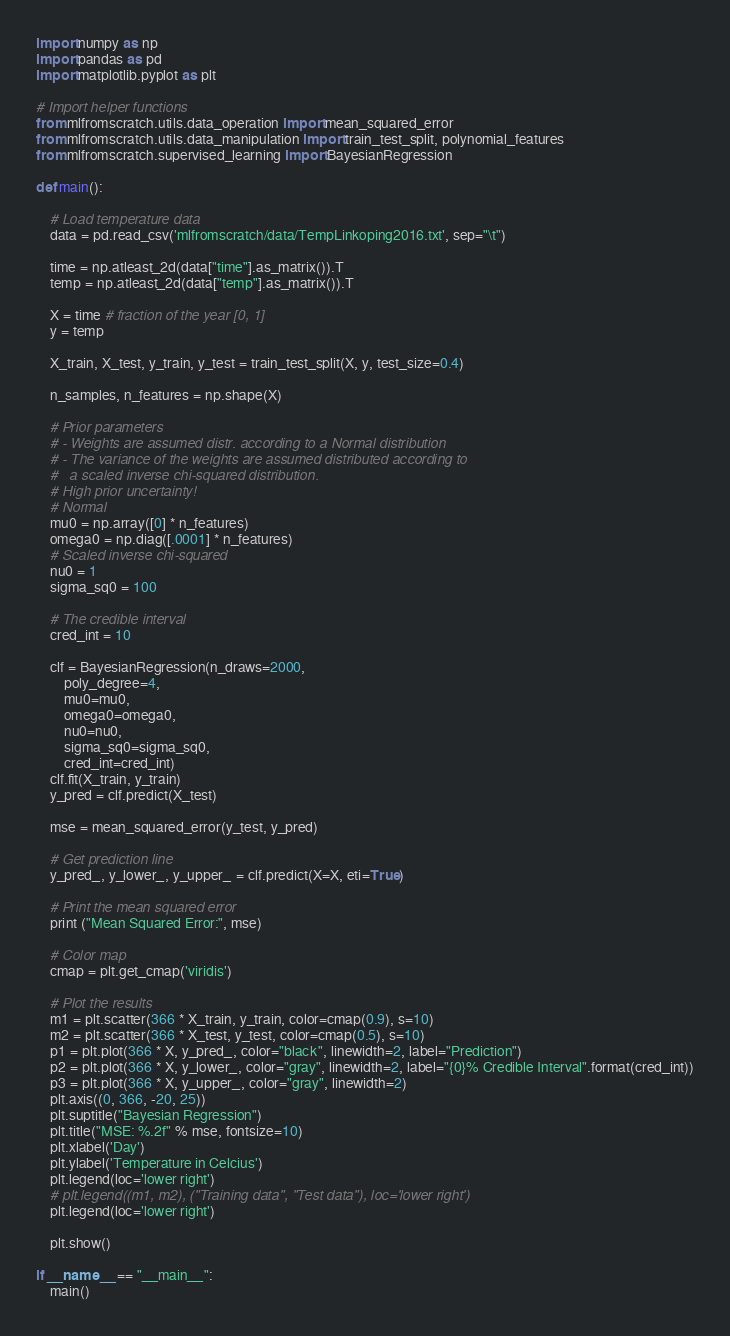<code> <loc_0><loc_0><loc_500><loc_500><_Python_>import numpy as np
import pandas as pd
import matplotlib.pyplot as plt

# Import helper functions
from mlfromscratch.utils.data_operation import mean_squared_error
from mlfromscratch.utils.data_manipulation import train_test_split, polynomial_features
from mlfromscratch.supervised_learning import BayesianRegression

def main():

    # Load temperature data
    data = pd.read_csv('mlfromscratch/data/TempLinkoping2016.txt', sep="\t")

    time = np.atleast_2d(data["time"].as_matrix()).T
    temp = np.atleast_2d(data["temp"].as_matrix()).T

    X = time # fraction of the year [0, 1]
    y = temp

    X_train, X_test, y_train, y_test = train_test_split(X, y, test_size=0.4)

    n_samples, n_features = np.shape(X)

    # Prior parameters
    # - Weights are assumed distr. according to a Normal distribution
    # - The variance of the weights are assumed distributed according to 
    #   a scaled inverse chi-squared distribution.
    # High prior uncertainty!
    # Normal
    mu0 = np.array([0] * n_features)
    omega0 = np.diag([.0001] * n_features)
    # Scaled inverse chi-squared
    nu0 = 1
    sigma_sq0 = 100

    # The credible interval
    cred_int = 10

    clf = BayesianRegression(n_draws=2000, 
        poly_degree=4, 
        mu0=mu0, 
        omega0=omega0, 
        nu0=nu0, 
        sigma_sq0=sigma_sq0,
        cred_int=cred_int)
    clf.fit(X_train, y_train)
    y_pred = clf.predict(X_test)

    mse = mean_squared_error(y_test, y_pred)

    # Get prediction line
    y_pred_, y_lower_, y_upper_ = clf.predict(X=X, eti=True)

    # Print the mean squared error
    print ("Mean Squared Error:", mse)

    # Color map
    cmap = plt.get_cmap('viridis')

    # Plot the results
    m1 = plt.scatter(366 * X_train, y_train, color=cmap(0.9), s=10)
    m2 = plt.scatter(366 * X_test, y_test, color=cmap(0.5), s=10)
    p1 = plt.plot(366 * X, y_pred_, color="black", linewidth=2, label="Prediction")
    p2 = plt.plot(366 * X, y_lower_, color="gray", linewidth=2, label="{0}% Credible Interval".format(cred_int))
    p3 = plt.plot(366 * X, y_upper_, color="gray", linewidth=2)
    plt.axis((0, 366, -20, 25))
    plt.suptitle("Bayesian Regression")
    plt.title("MSE: %.2f" % mse, fontsize=10)
    plt.xlabel('Day')
    plt.ylabel('Temperature in Celcius')
    plt.legend(loc='lower right')
    # plt.legend((m1, m2), ("Training data", "Test data"), loc='lower right')
    plt.legend(loc='lower right')

    plt.show()

if __name__ == "__main__":
    main()</code> 